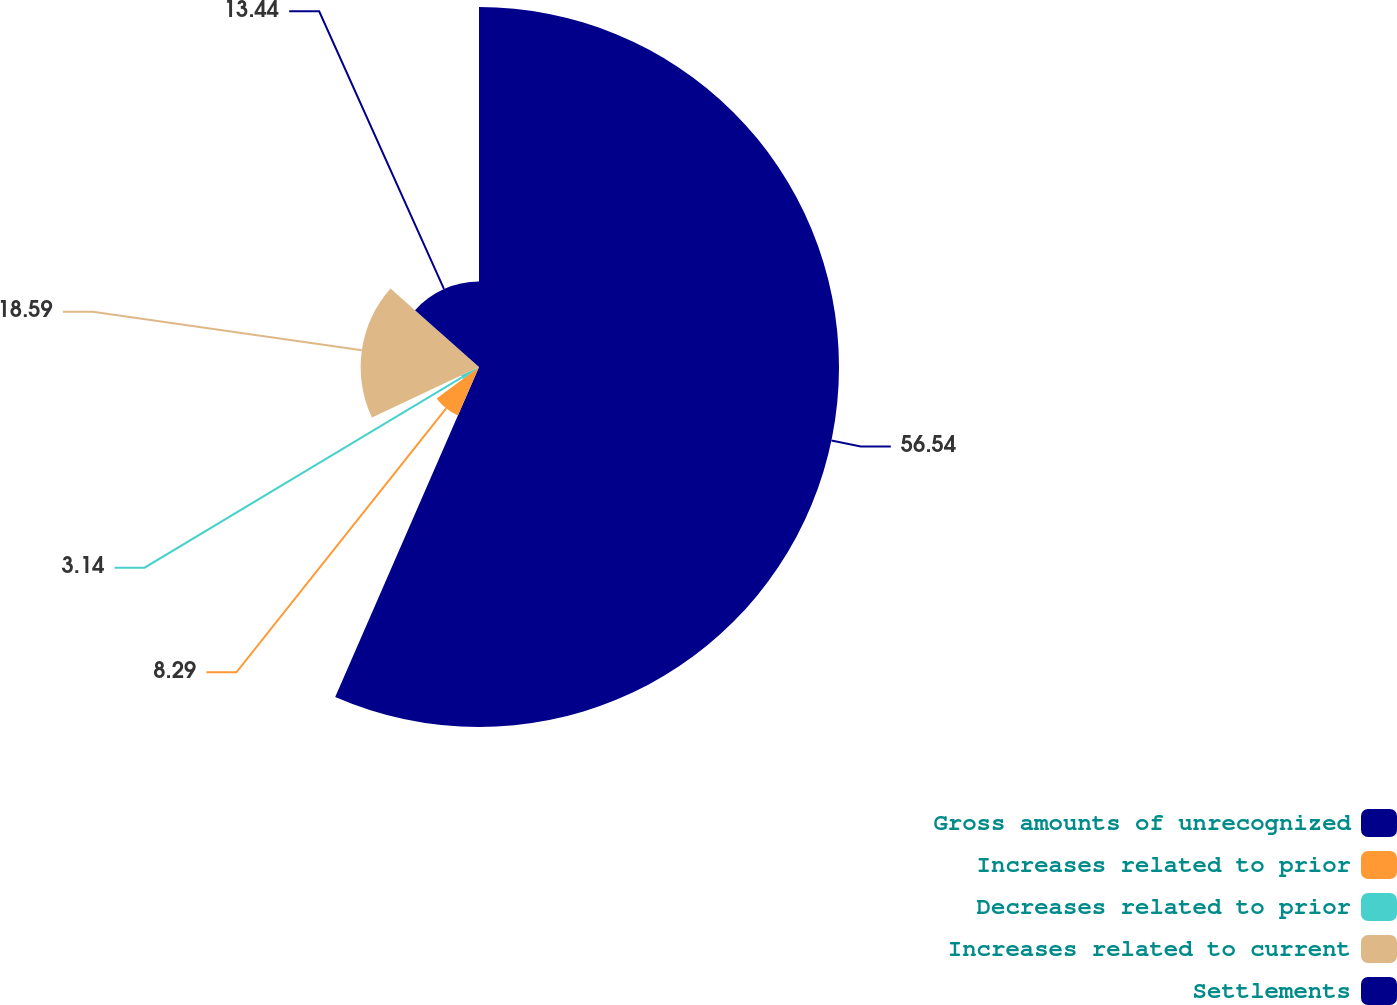<chart> <loc_0><loc_0><loc_500><loc_500><pie_chart><fcel>Gross amounts of unrecognized<fcel>Increases related to prior<fcel>Decreases related to prior<fcel>Increases related to current<fcel>Settlements<nl><fcel>56.54%<fcel>8.29%<fcel>3.14%<fcel>18.59%<fcel>13.44%<nl></chart> 